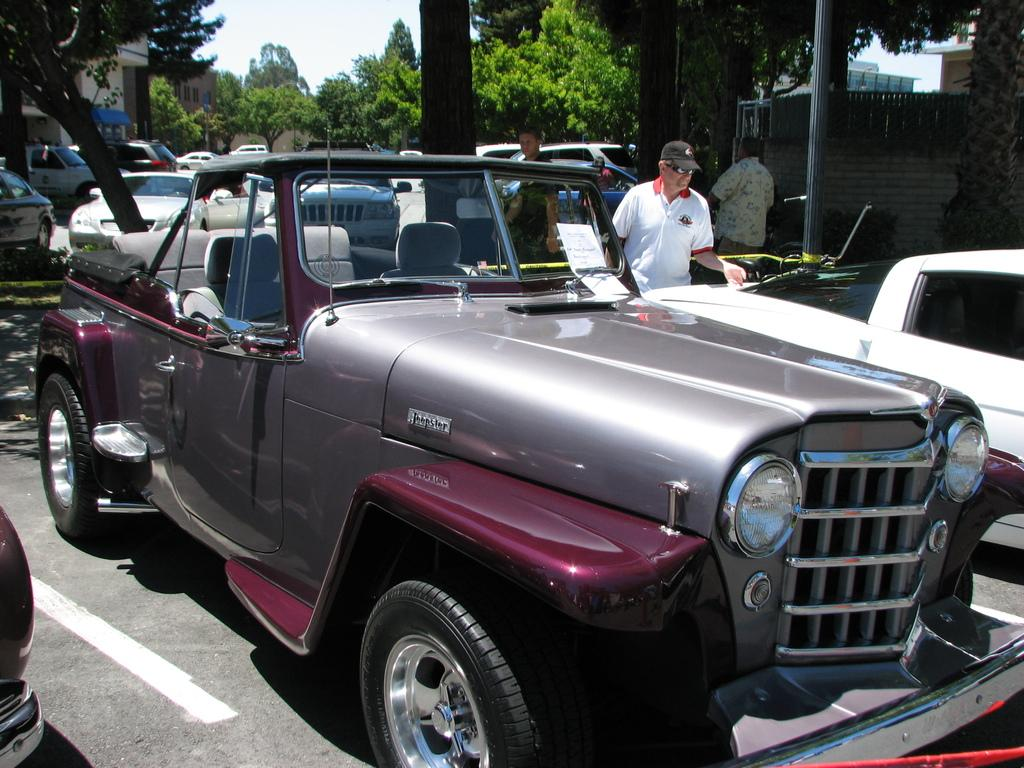What can be seen on the road in the image? There are vehicles parked on the road in the image. Are there any people present in the image? Yes, there are people standing in the image. What type of natural elements can be seen in the image? There are trees visible in the image. What type of man-made structures can be seen in the image? There are buildings in the image. What color is the skirt worn by the person in the image? There is no skirt present in the image; the people are not wearing any clothing that resembles a skirt. How does the feeling of the trees buildings in the image make you feel? This question is not relevant to the image, as it asks about a feeling, which cannot be determined from the image. 